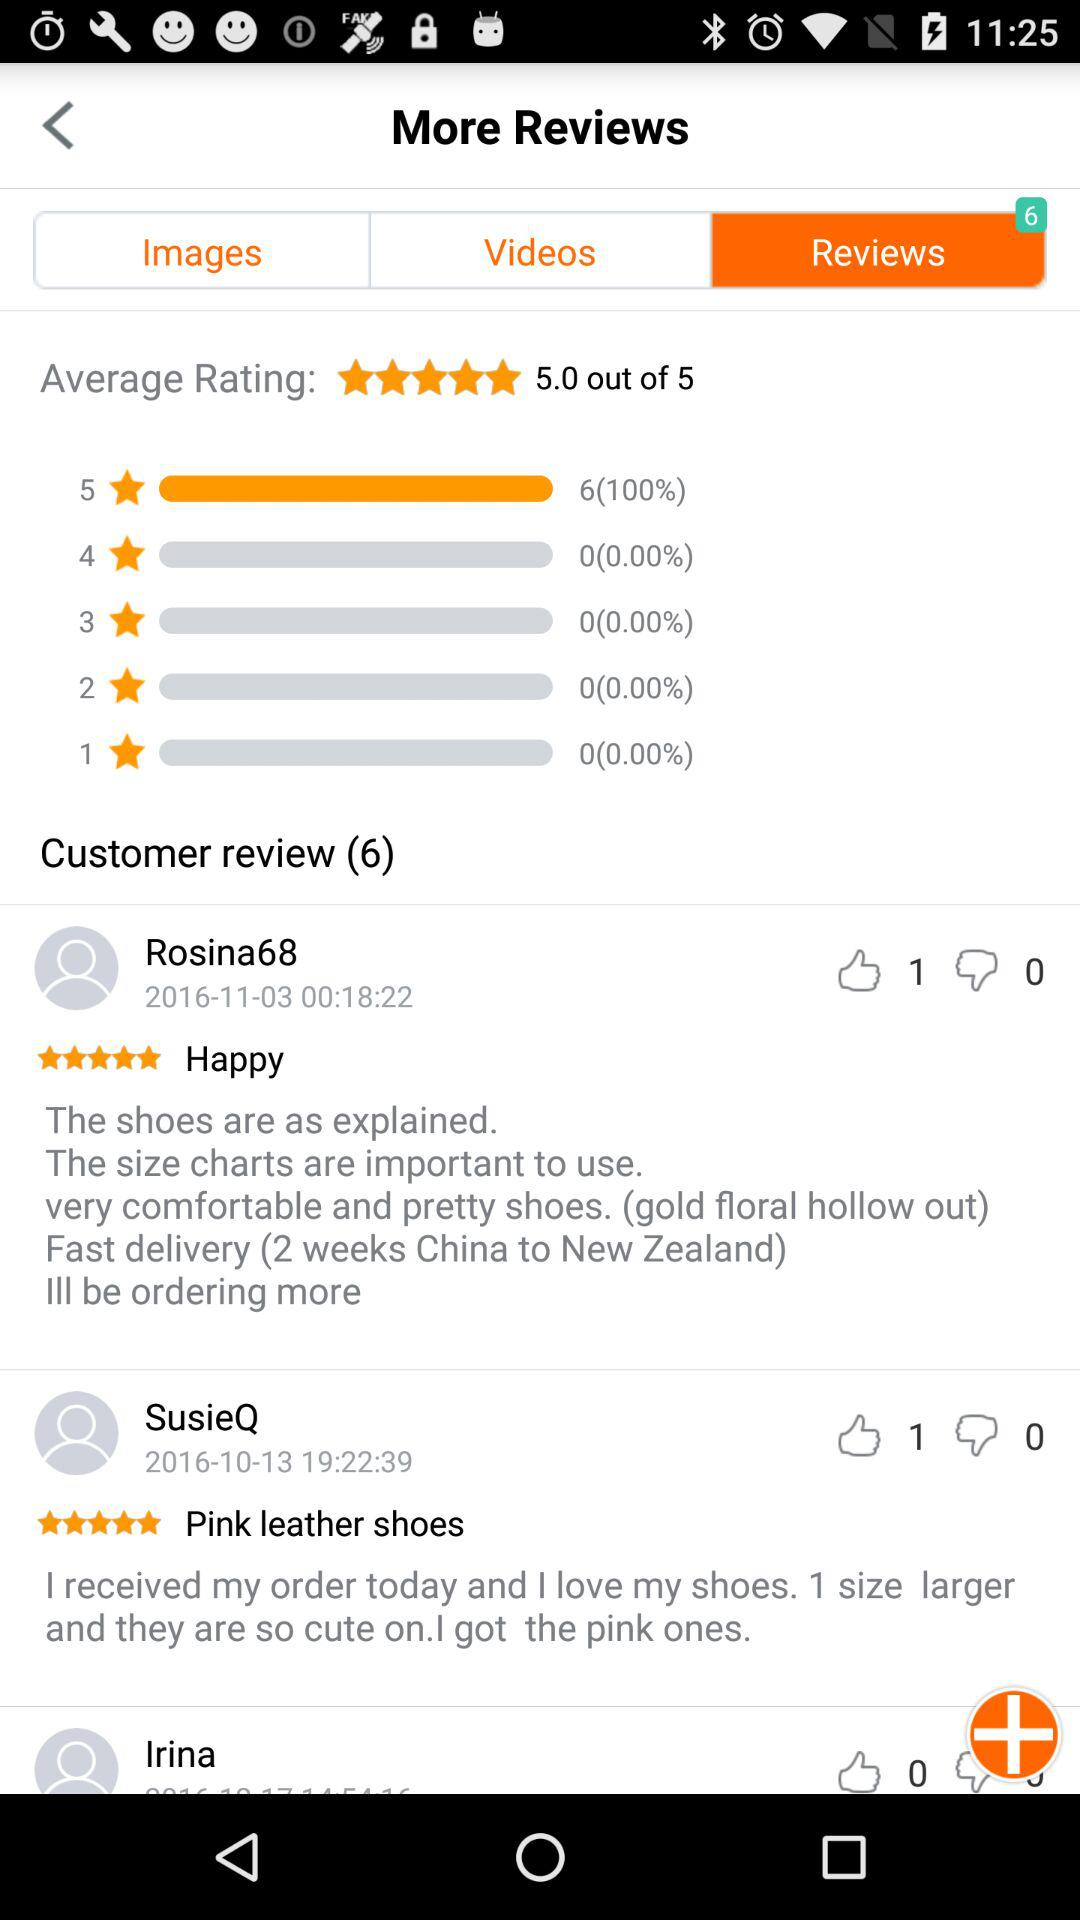How many dislikes are there on the review by "SusieQ"? There are 0 dislikes on the review by "SusieQ". 